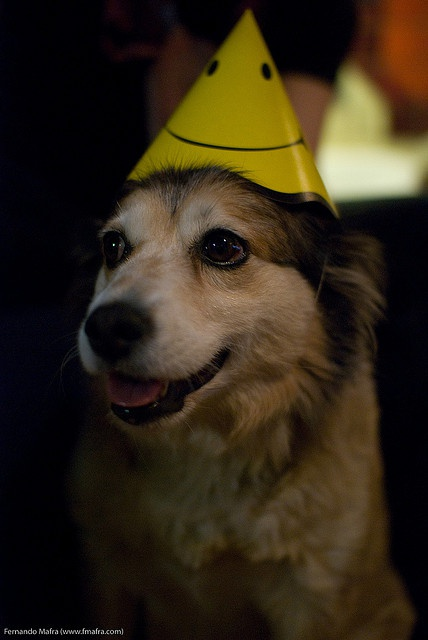Describe the objects in this image and their specific colors. I can see a dog in black, maroon, and gray tones in this image. 